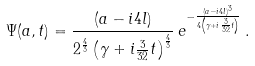<formula> <loc_0><loc_0><loc_500><loc_500>\Psi ( a , t ) = \frac { ( a - i 4 l ) } { 2 ^ { \frac { 4 } { 3 } } \left ( \gamma + i \frac { 3 } { 3 2 } t \right ) ^ { \frac { 4 } { 3 } } } \, e ^ { - \frac { ( a - i 4 l ) ^ { 3 } } { 4 \left ( \gamma + i \frac { 3 } { 3 2 } t \right ) } } \, .</formula> 